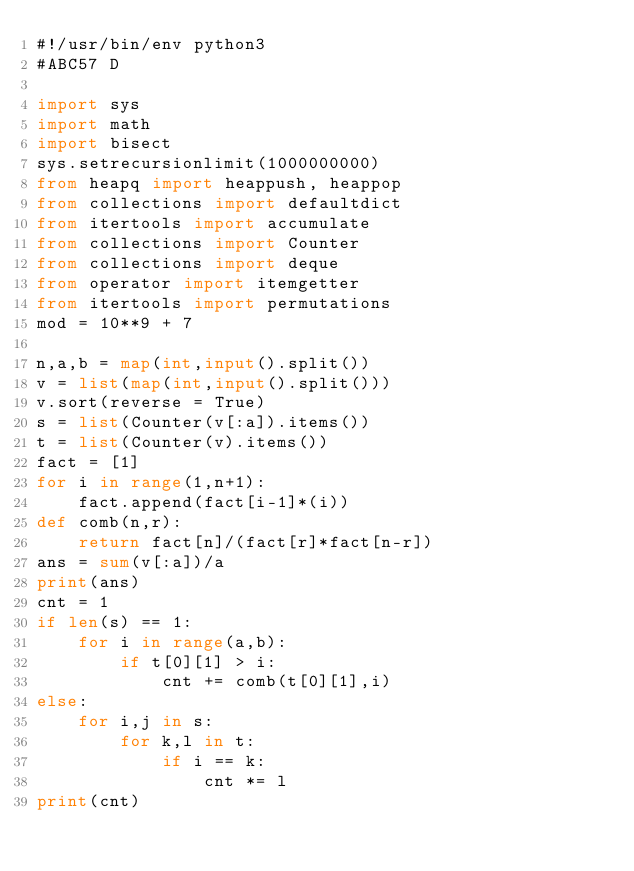Convert code to text. <code><loc_0><loc_0><loc_500><loc_500><_Python_>#!/usr/bin/env python3
#ABC57 D

import sys
import math
import bisect
sys.setrecursionlimit(1000000000)
from heapq import heappush, heappop
from collections import defaultdict
from itertools import accumulate
from collections import Counter
from collections import deque
from operator import itemgetter
from itertools import permutations
mod = 10**9 + 7

n,a,b = map(int,input().split())
v = list(map(int,input().split()))
v.sort(reverse = True)
s = list(Counter(v[:a]).items())
t = list(Counter(v).items())
fact = [1]
for i in range(1,n+1):
    fact.append(fact[i-1]*(i))
def comb(n,r):
    return fact[n]/(fact[r]*fact[n-r])
ans = sum(v[:a])/a
print(ans)
cnt = 1
if len(s) == 1:
    for i in range(a,b):
        if t[0][1] > i:
            cnt += comb(t[0][1],i)
else:
    for i,j in s:
        for k,l in t:
            if i == k:
                cnt *= l
print(cnt)
</code> 